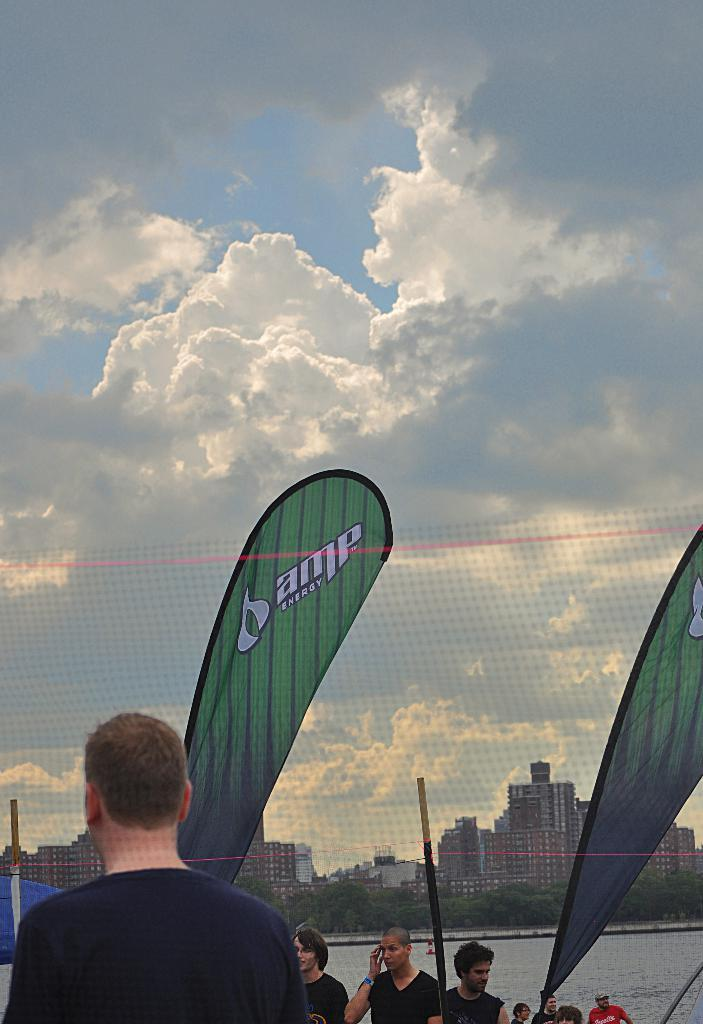What is the main object in the image? There is a net in the image. What are the people near the net doing? The people standing near the net suggest that they might be playing a game or sport. What can be seen in the background of the image? There are trees, buildings, and the sky visible in the background of the image. Can you describe the sky in the image? The sky is visible in the background of the image, with clouds present. How many pigs are swimming in the water surface in the image? There are no pigs present in the image; it features a net, people, and a water surface with no animals visible. What type of duck can be seen interacting with the people near the net? There is no duck present in the image; it only features a net, people, and a water surface. 